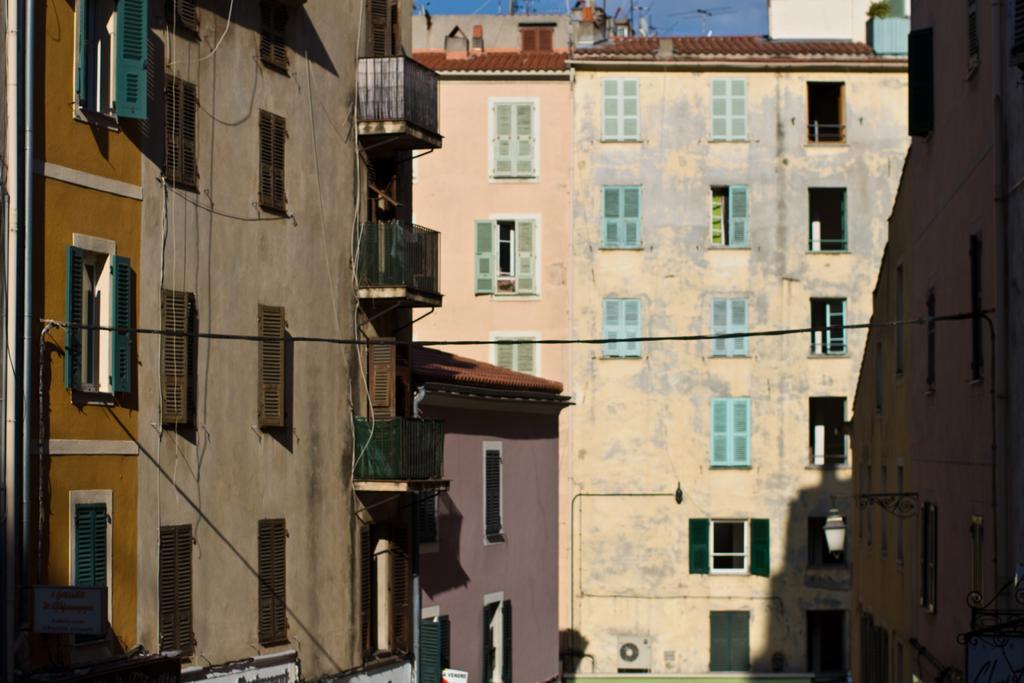How would you summarize this image in a sentence or two? In the center of the image there is a building. There are windows. To both the sides of the image there are buildings. 